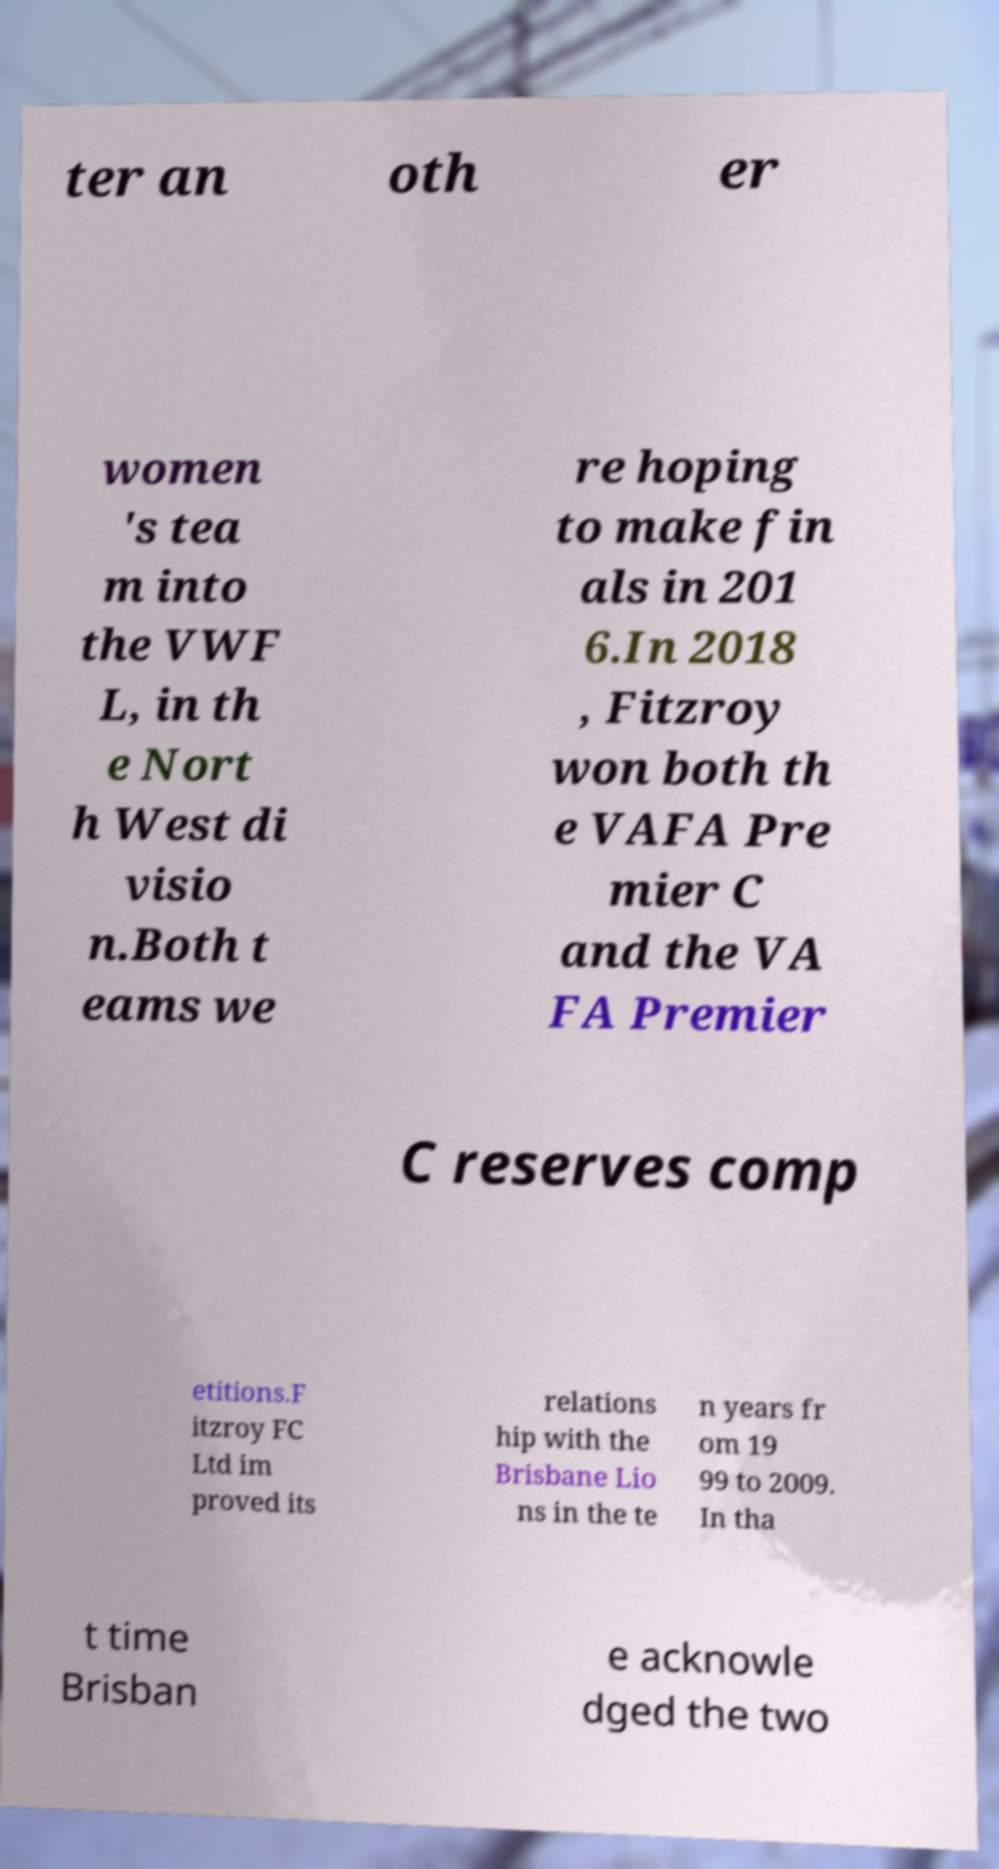There's text embedded in this image that I need extracted. Can you transcribe it verbatim? ter an oth er women 's tea m into the VWF L, in th e Nort h West di visio n.Both t eams we re hoping to make fin als in 201 6.In 2018 , Fitzroy won both th e VAFA Pre mier C and the VA FA Premier C reserves comp etitions.F itzroy FC Ltd im proved its relations hip with the Brisbane Lio ns in the te n years fr om 19 99 to 2009. In tha t time Brisban e acknowle dged the two 